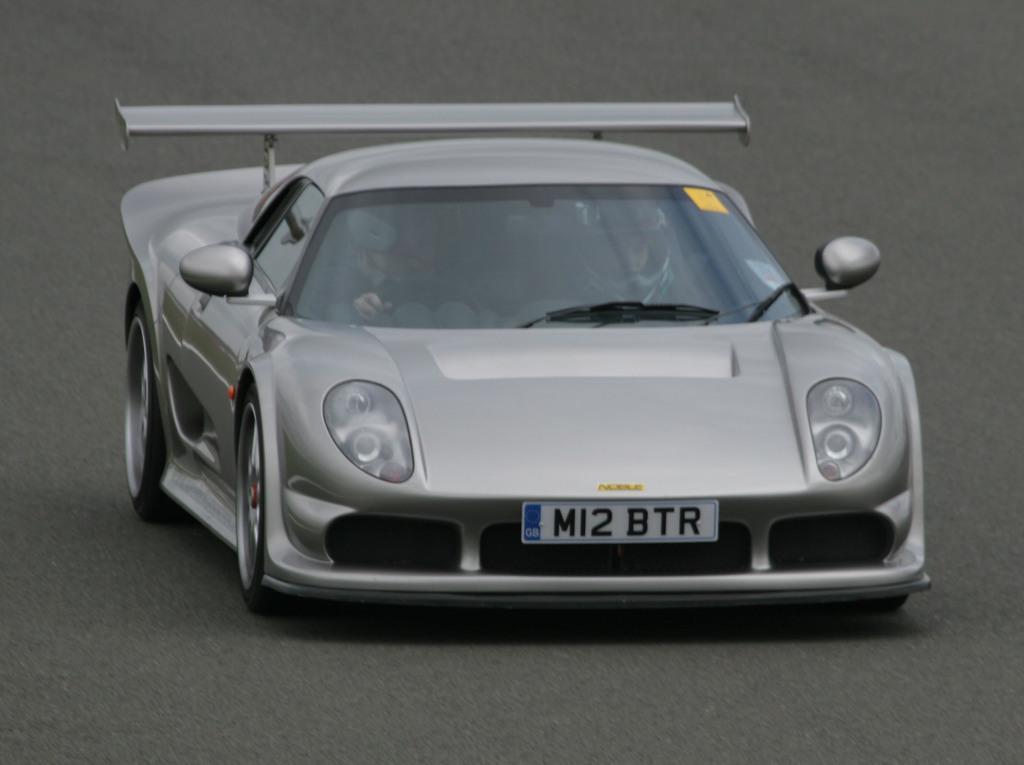Could you give a brief overview of what you see in this image? In this image there is a car moving on the road with the persons sitting inside it with some text and numbers written on it. 